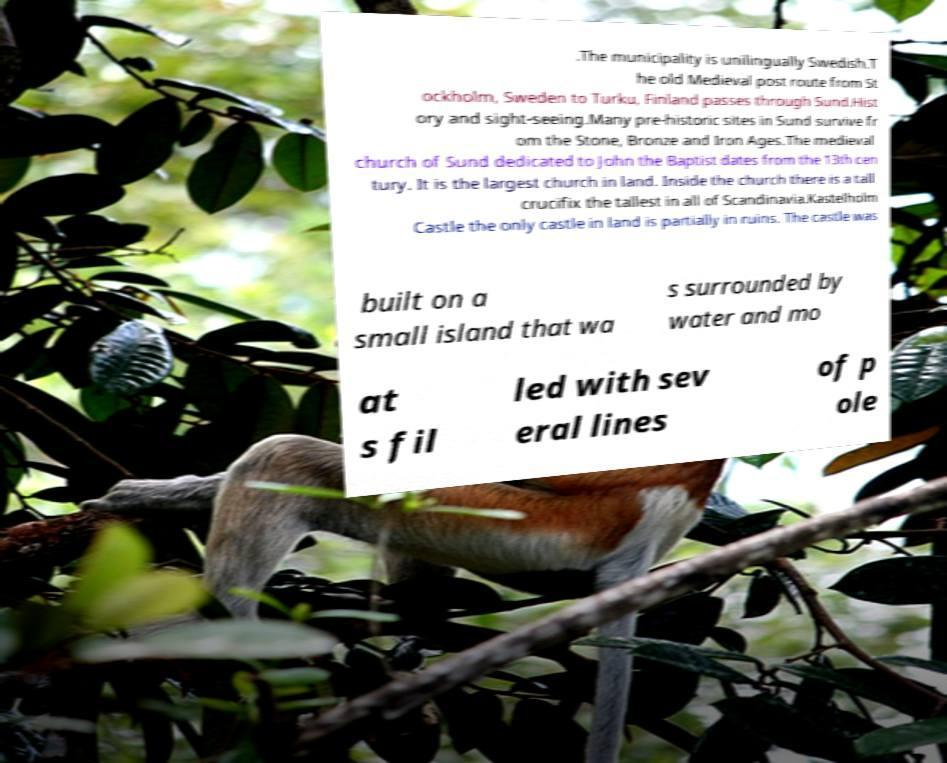For documentation purposes, I need the text within this image transcribed. Could you provide that? .The municipality is unilingually Swedish.T he old Medieval post route from St ockholm, Sweden to Turku, Finland passes through Sund.Hist ory and sight-seeing.Many pre-historic sites in Sund survive fr om the Stone, Bronze and Iron Ages.The medieval church of Sund dedicated to John the Baptist dates from the 13th cen tury. It is the largest church in land. Inside the church there is a tall crucifix the tallest in all of Scandinavia.Kastelholm Castle the only castle in land is partially in ruins. The castle was built on a small island that wa s surrounded by water and mo at s fil led with sev eral lines of p ole 